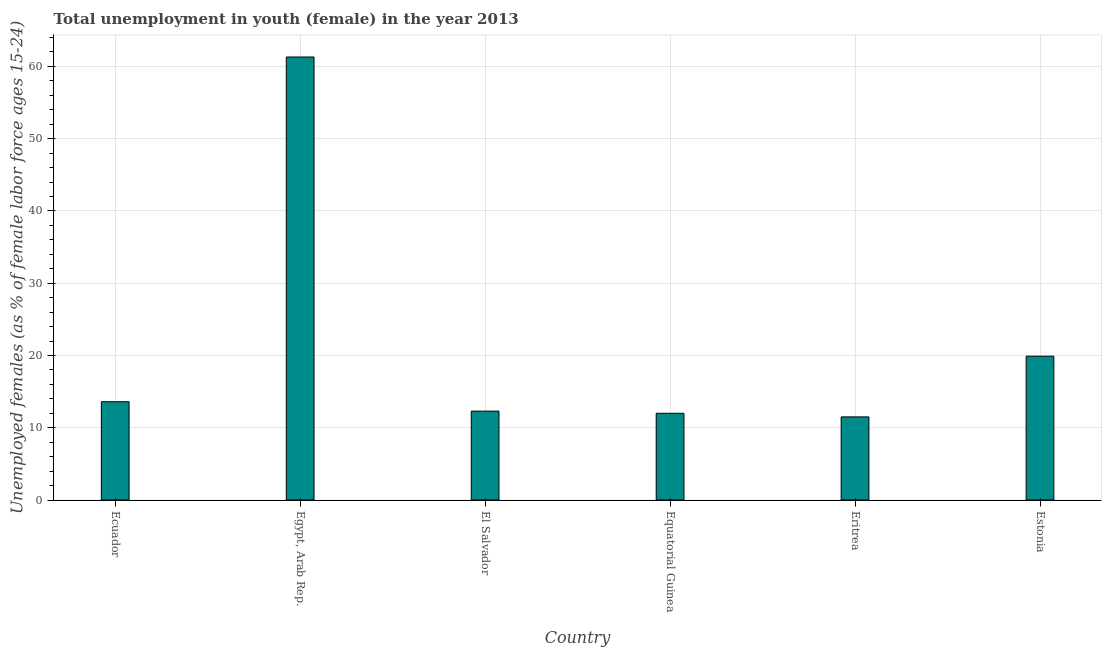Does the graph contain grids?
Offer a very short reply. Yes. What is the title of the graph?
Provide a succinct answer. Total unemployment in youth (female) in the year 2013. What is the label or title of the X-axis?
Ensure brevity in your answer.  Country. What is the label or title of the Y-axis?
Provide a short and direct response. Unemployed females (as % of female labor force ages 15-24). What is the unemployed female youth population in Ecuador?
Your response must be concise. 13.6. Across all countries, what is the maximum unemployed female youth population?
Make the answer very short. 61.3. Across all countries, what is the minimum unemployed female youth population?
Your response must be concise. 11.5. In which country was the unemployed female youth population maximum?
Your answer should be compact. Egypt, Arab Rep. In which country was the unemployed female youth population minimum?
Provide a succinct answer. Eritrea. What is the sum of the unemployed female youth population?
Provide a short and direct response. 130.6. What is the difference between the unemployed female youth population in Egypt, Arab Rep. and Equatorial Guinea?
Give a very brief answer. 49.3. What is the average unemployed female youth population per country?
Make the answer very short. 21.77. What is the median unemployed female youth population?
Provide a succinct answer. 12.95. What is the ratio of the unemployed female youth population in Egypt, Arab Rep. to that in Eritrea?
Keep it short and to the point. 5.33. Is the unemployed female youth population in Equatorial Guinea less than that in Estonia?
Provide a succinct answer. Yes. What is the difference between the highest and the second highest unemployed female youth population?
Provide a short and direct response. 41.4. What is the difference between the highest and the lowest unemployed female youth population?
Keep it short and to the point. 49.8. In how many countries, is the unemployed female youth population greater than the average unemployed female youth population taken over all countries?
Your response must be concise. 1. How many countries are there in the graph?
Keep it short and to the point. 6. Are the values on the major ticks of Y-axis written in scientific E-notation?
Give a very brief answer. No. What is the Unemployed females (as % of female labor force ages 15-24) in Ecuador?
Offer a terse response. 13.6. What is the Unemployed females (as % of female labor force ages 15-24) of Egypt, Arab Rep.?
Ensure brevity in your answer.  61.3. What is the Unemployed females (as % of female labor force ages 15-24) of El Salvador?
Offer a terse response. 12.3. What is the Unemployed females (as % of female labor force ages 15-24) in Equatorial Guinea?
Ensure brevity in your answer.  12. What is the Unemployed females (as % of female labor force ages 15-24) in Eritrea?
Your answer should be compact. 11.5. What is the Unemployed females (as % of female labor force ages 15-24) in Estonia?
Your response must be concise. 19.9. What is the difference between the Unemployed females (as % of female labor force ages 15-24) in Ecuador and Egypt, Arab Rep.?
Give a very brief answer. -47.7. What is the difference between the Unemployed females (as % of female labor force ages 15-24) in Ecuador and Equatorial Guinea?
Provide a short and direct response. 1.6. What is the difference between the Unemployed females (as % of female labor force ages 15-24) in Ecuador and Estonia?
Keep it short and to the point. -6.3. What is the difference between the Unemployed females (as % of female labor force ages 15-24) in Egypt, Arab Rep. and Equatorial Guinea?
Your answer should be compact. 49.3. What is the difference between the Unemployed females (as % of female labor force ages 15-24) in Egypt, Arab Rep. and Eritrea?
Keep it short and to the point. 49.8. What is the difference between the Unemployed females (as % of female labor force ages 15-24) in Egypt, Arab Rep. and Estonia?
Your answer should be compact. 41.4. What is the difference between the Unemployed females (as % of female labor force ages 15-24) in Equatorial Guinea and Eritrea?
Offer a very short reply. 0.5. What is the difference between the Unemployed females (as % of female labor force ages 15-24) in Eritrea and Estonia?
Offer a very short reply. -8.4. What is the ratio of the Unemployed females (as % of female labor force ages 15-24) in Ecuador to that in Egypt, Arab Rep.?
Offer a very short reply. 0.22. What is the ratio of the Unemployed females (as % of female labor force ages 15-24) in Ecuador to that in El Salvador?
Offer a very short reply. 1.11. What is the ratio of the Unemployed females (as % of female labor force ages 15-24) in Ecuador to that in Equatorial Guinea?
Your answer should be compact. 1.13. What is the ratio of the Unemployed females (as % of female labor force ages 15-24) in Ecuador to that in Eritrea?
Provide a succinct answer. 1.18. What is the ratio of the Unemployed females (as % of female labor force ages 15-24) in Ecuador to that in Estonia?
Provide a short and direct response. 0.68. What is the ratio of the Unemployed females (as % of female labor force ages 15-24) in Egypt, Arab Rep. to that in El Salvador?
Provide a succinct answer. 4.98. What is the ratio of the Unemployed females (as % of female labor force ages 15-24) in Egypt, Arab Rep. to that in Equatorial Guinea?
Provide a short and direct response. 5.11. What is the ratio of the Unemployed females (as % of female labor force ages 15-24) in Egypt, Arab Rep. to that in Eritrea?
Your answer should be very brief. 5.33. What is the ratio of the Unemployed females (as % of female labor force ages 15-24) in Egypt, Arab Rep. to that in Estonia?
Your answer should be compact. 3.08. What is the ratio of the Unemployed females (as % of female labor force ages 15-24) in El Salvador to that in Eritrea?
Give a very brief answer. 1.07. What is the ratio of the Unemployed females (as % of female labor force ages 15-24) in El Salvador to that in Estonia?
Ensure brevity in your answer.  0.62. What is the ratio of the Unemployed females (as % of female labor force ages 15-24) in Equatorial Guinea to that in Eritrea?
Offer a very short reply. 1.04. What is the ratio of the Unemployed females (as % of female labor force ages 15-24) in Equatorial Guinea to that in Estonia?
Offer a terse response. 0.6. What is the ratio of the Unemployed females (as % of female labor force ages 15-24) in Eritrea to that in Estonia?
Keep it short and to the point. 0.58. 